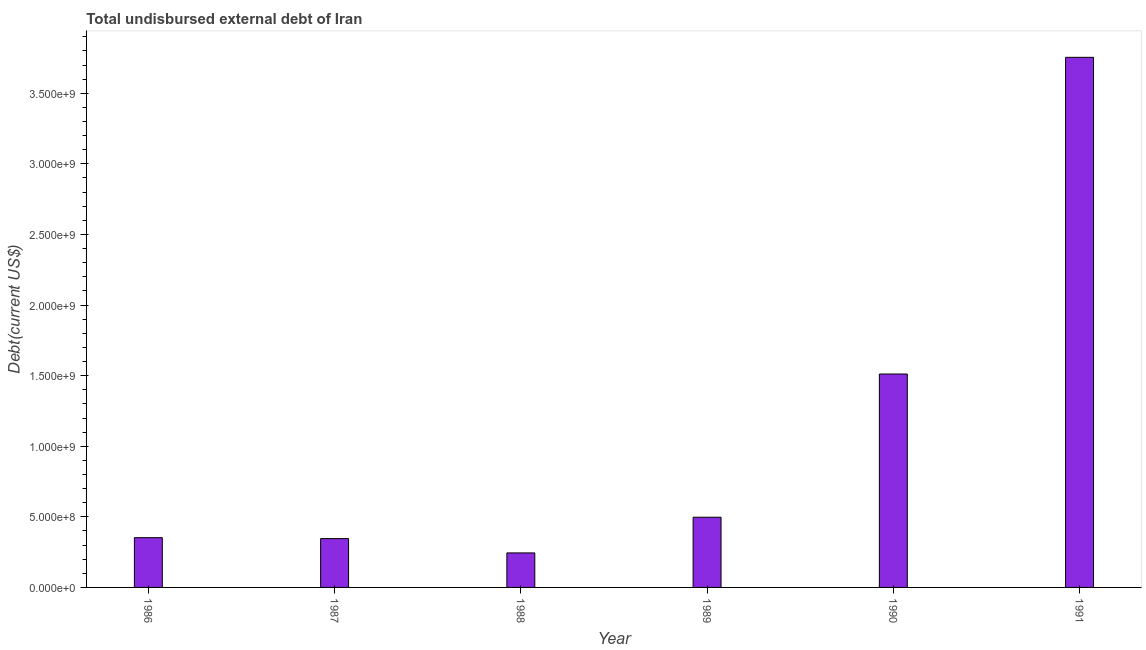Does the graph contain any zero values?
Provide a succinct answer. No. What is the title of the graph?
Your response must be concise. Total undisbursed external debt of Iran. What is the label or title of the X-axis?
Make the answer very short. Year. What is the label or title of the Y-axis?
Give a very brief answer. Debt(current US$). What is the total debt in 1986?
Ensure brevity in your answer.  3.52e+08. Across all years, what is the maximum total debt?
Ensure brevity in your answer.  3.75e+09. Across all years, what is the minimum total debt?
Your answer should be very brief. 2.44e+08. What is the sum of the total debt?
Provide a succinct answer. 6.71e+09. What is the difference between the total debt in 1989 and 1990?
Ensure brevity in your answer.  -1.01e+09. What is the average total debt per year?
Offer a very short reply. 1.12e+09. What is the median total debt?
Provide a short and direct response. 4.25e+08. In how many years, is the total debt greater than 2600000000 US$?
Offer a very short reply. 1. What is the ratio of the total debt in 1986 to that in 1991?
Provide a short and direct response. 0.09. What is the difference between the highest and the second highest total debt?
Provide a succinct answer. 2.24e+09. Is the sum of the total debt in 1989 and 1991 greater than the maximum total debt across all years?
Give a very brief answer. Yes. What is the difference between the highest and the lowest total debt?
Keep it short and to the point. 3.51e+09. In how many years, is the total debt greater than the average total debt taken over all years?
Provide a succinct answer. 2. How many years are there in the graph?
Give a very brief answer. 6. What is the difference between two consecutive major ticks on the Y-axis?
Give a very brief answer. 5.00e+08. Are the values on the major ticks of Y-axis written in scientific E-notation?
Ensure brevity in your answer.  Yes. What is the Debt(current US$) of 1986?
Provide a short and direct response. 3.52e+08. What is the Debt(current US$) in 1987?
Offer a terse response. 3.46e+08. What is the Debt(current US$) of 1988?
Give a very brief answer. 2.44e+08. What is the Debt(current US$) of 1989?
Ensure brevity in your answer.  4.97e+08. What is the Debt(current US$) in 1990?
Provide a short and direct response. 1.51e+09. What is the Debt(current US$) in 1991?
Provide a short and direct response. 3.75e+09. What is the difference between the Debt(current US$) in 1986 and 1987?
Offer a very short reply. 6.60e+06. What is the difference between the Debt(current US$) in 1986 and 1988?
Make the answer very short. 1.08e+08. What is the difference between the Debt(current US$) in 1986 and 1989?
Give a very brief answer. -1.45e+08. What is the difference between the Debt(current US$) in 1986 and 1990?
Keep it short and to the point. -1.16e+09. What is the difference between the Debt(current US$) in 1986 and 1991?
Ensure brevity in your answer.  -3.40e+09. What is the difference between the Debt(current US$) in 1987 and 1988?
Give a very brief answer. 1.01e+08. What is the difference between the Debt(current US$) in 1987 and 1989?
Ensure brevity in your answer.  -1.51e+08. What is the difference between the Debt(current US$) in 1987 and 1990?
Your answer should be very brief. -1.17e+09. What is the difference between the Debt(current US$) in 1987 and 1991?
Ensure brevity in your answer.  -3.41e+09. What is the difference between the Debt(current US$) in 1988 and 1989?
Offer a very short reply. -2.53e+08. What is the difference between the Debt(current US$) in 1988 and 1990?
Give a very brief answer. -1.27e+09. What is the difference between the Debt(current US$) in 1988 and 1991?
Keep it short and to the point. -3.51e+09. What is the difference between the Debt(current US$) in 1989 and 1990?
Ensure brevity in your answer.  -1.01e+09. What is the difference between the Debt(current US$) in 1989 and 1991?
Give a very brief answer. -3.26e+09. What is the difference between the Debt(current US$) in 1990 and 1991?
Give a very brief answer. -2.24e+09. What is the ratio of the Debt(current US$) in 1986 to that in 1988?
Keep it short and to the point. 1.44. What is the ratio of the Debt(current US$) in 1986 to that in 1989?
Ensure brevity in your answer.  0.71. What is the ratio of the Debt(current US$) in 1986 to that in 1990?
Your answer should be very brief. 0.23. What is the ratio of the Debt(current US$) in 1986 to that in 1991?
Give a very brief answer. 0.09. What is the ratio of the Debt(current US$) in 1987 to that in 1988?
Provide a succinct answer. 1.42. What is the ratio of the Debt(current US$) in 1987 to that in 1989?
Make the answer very short. 0.7. What is the ratio of the Debt(current US$) in 1987 to that in 1990?
Offer a terse response. 0.23. What is the ratio of the Debt(current US$) in 1987 to that in 1991?
Give a very brief answer. 0.09. What is the ratio of the Debt(current US$) in 1988 to that in 1989?
Offer a very short reply. 0.49. What is the ratio of the Debt(current US$) in 1988 to that in 1990?
Your response must be concise. 0.16. What is the ratio of the Debt(current US$) in 1988 to that in 1991?
Your answer should be very brief. 0.07. What is the ratio of the Debt(current US$) in 1989 to that in 1990?
Your answer should be very brief. 0.33. What is the ratio of the Debt(current US$) in 1989 to that in 1991?
Offer a very short reply. 0.13. What is the ratio of the Debt(current US$) in 1990 to that in 1991?
Your response must be concise. 0.4. 